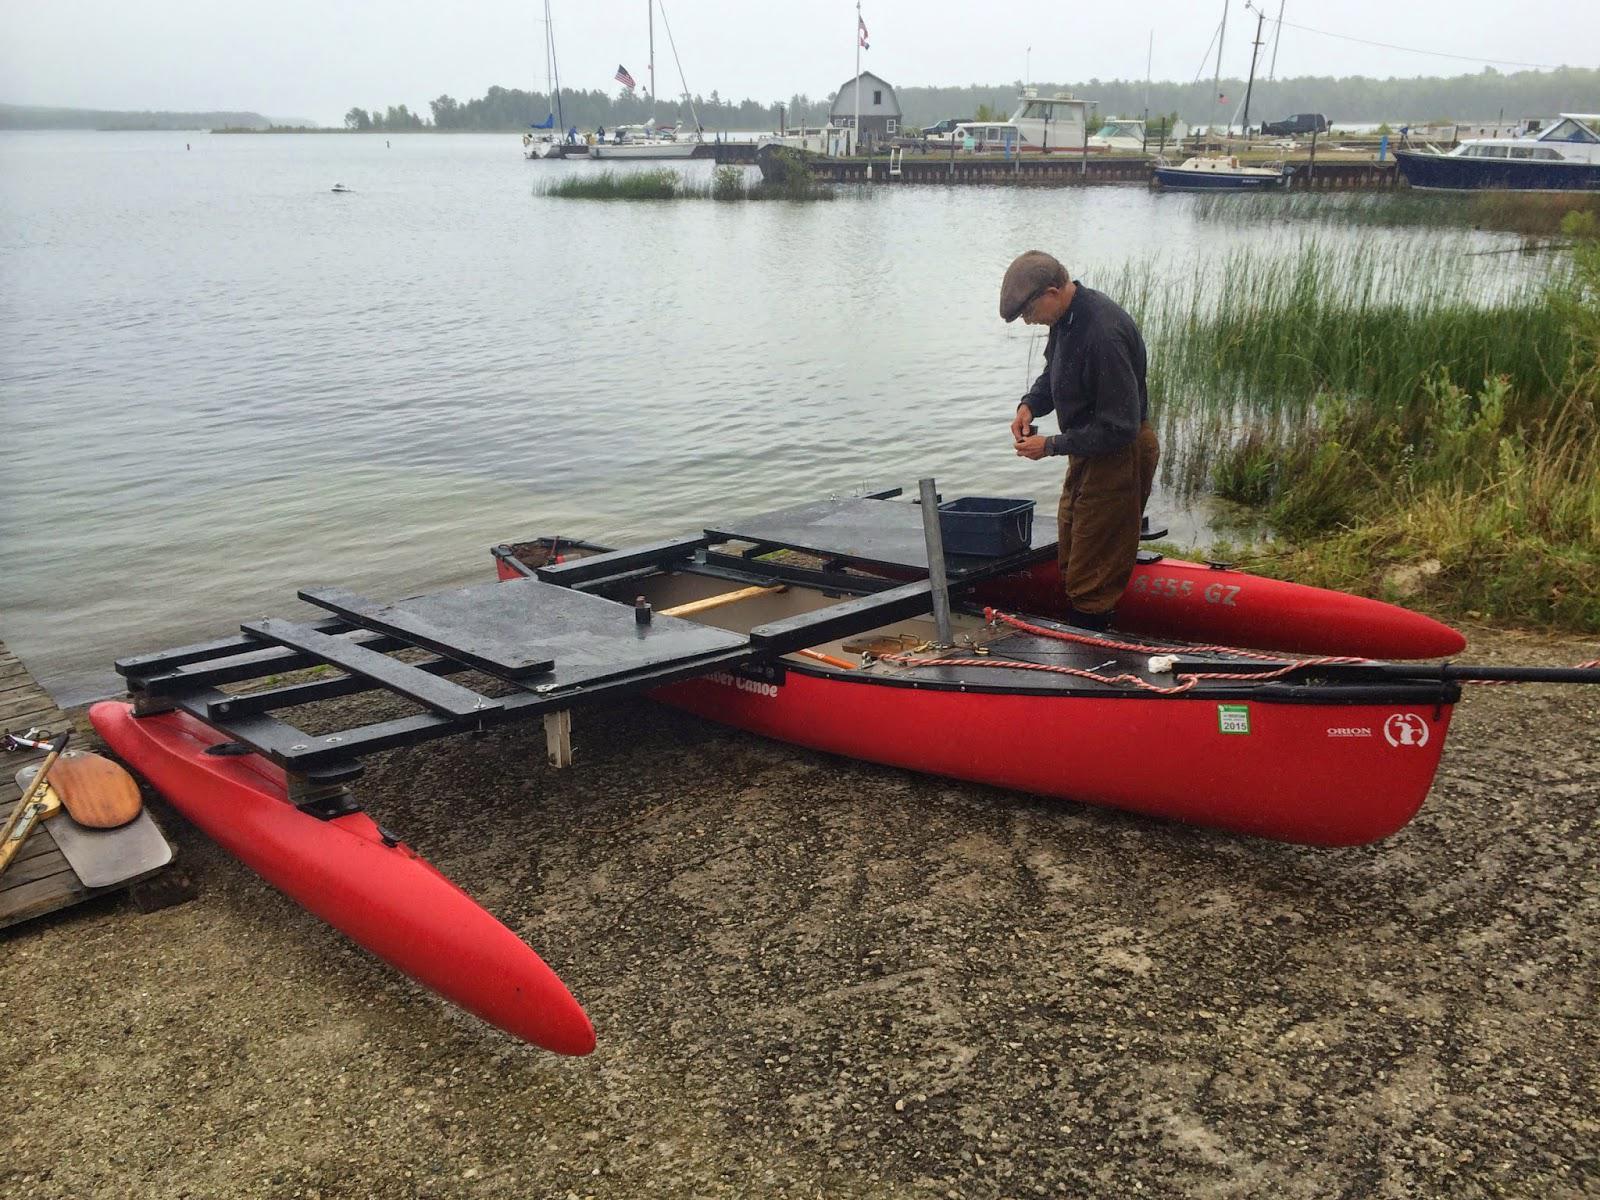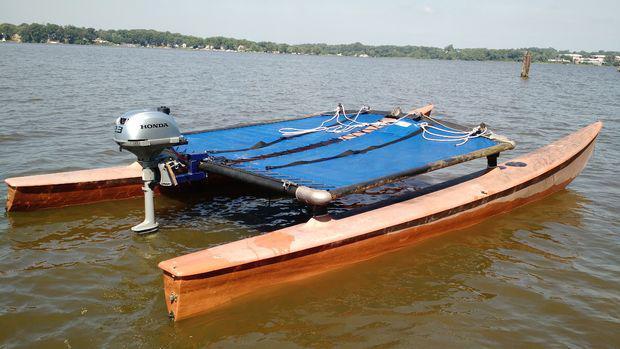The first image is the image on the left, the second image is the image on the right. Evaluate the accuracy of this statement regarding the images: "An image shows one watercraft made of three floating red parts joined on top by a rectangular shape.". Is it true? Answer yes or no. Yes. 